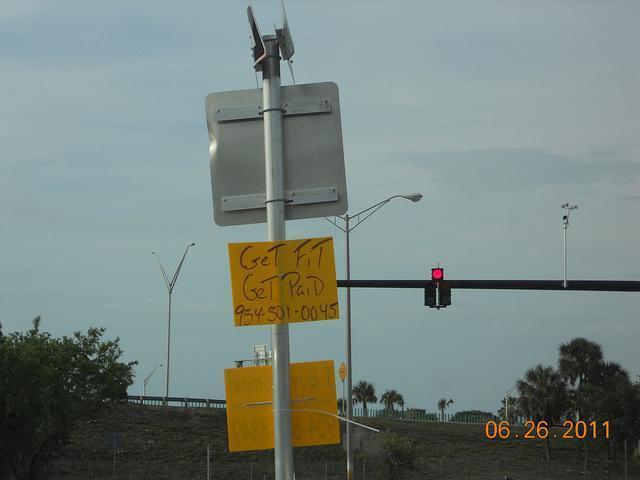How many people in the photo?
Give a very brief answer. 0. 